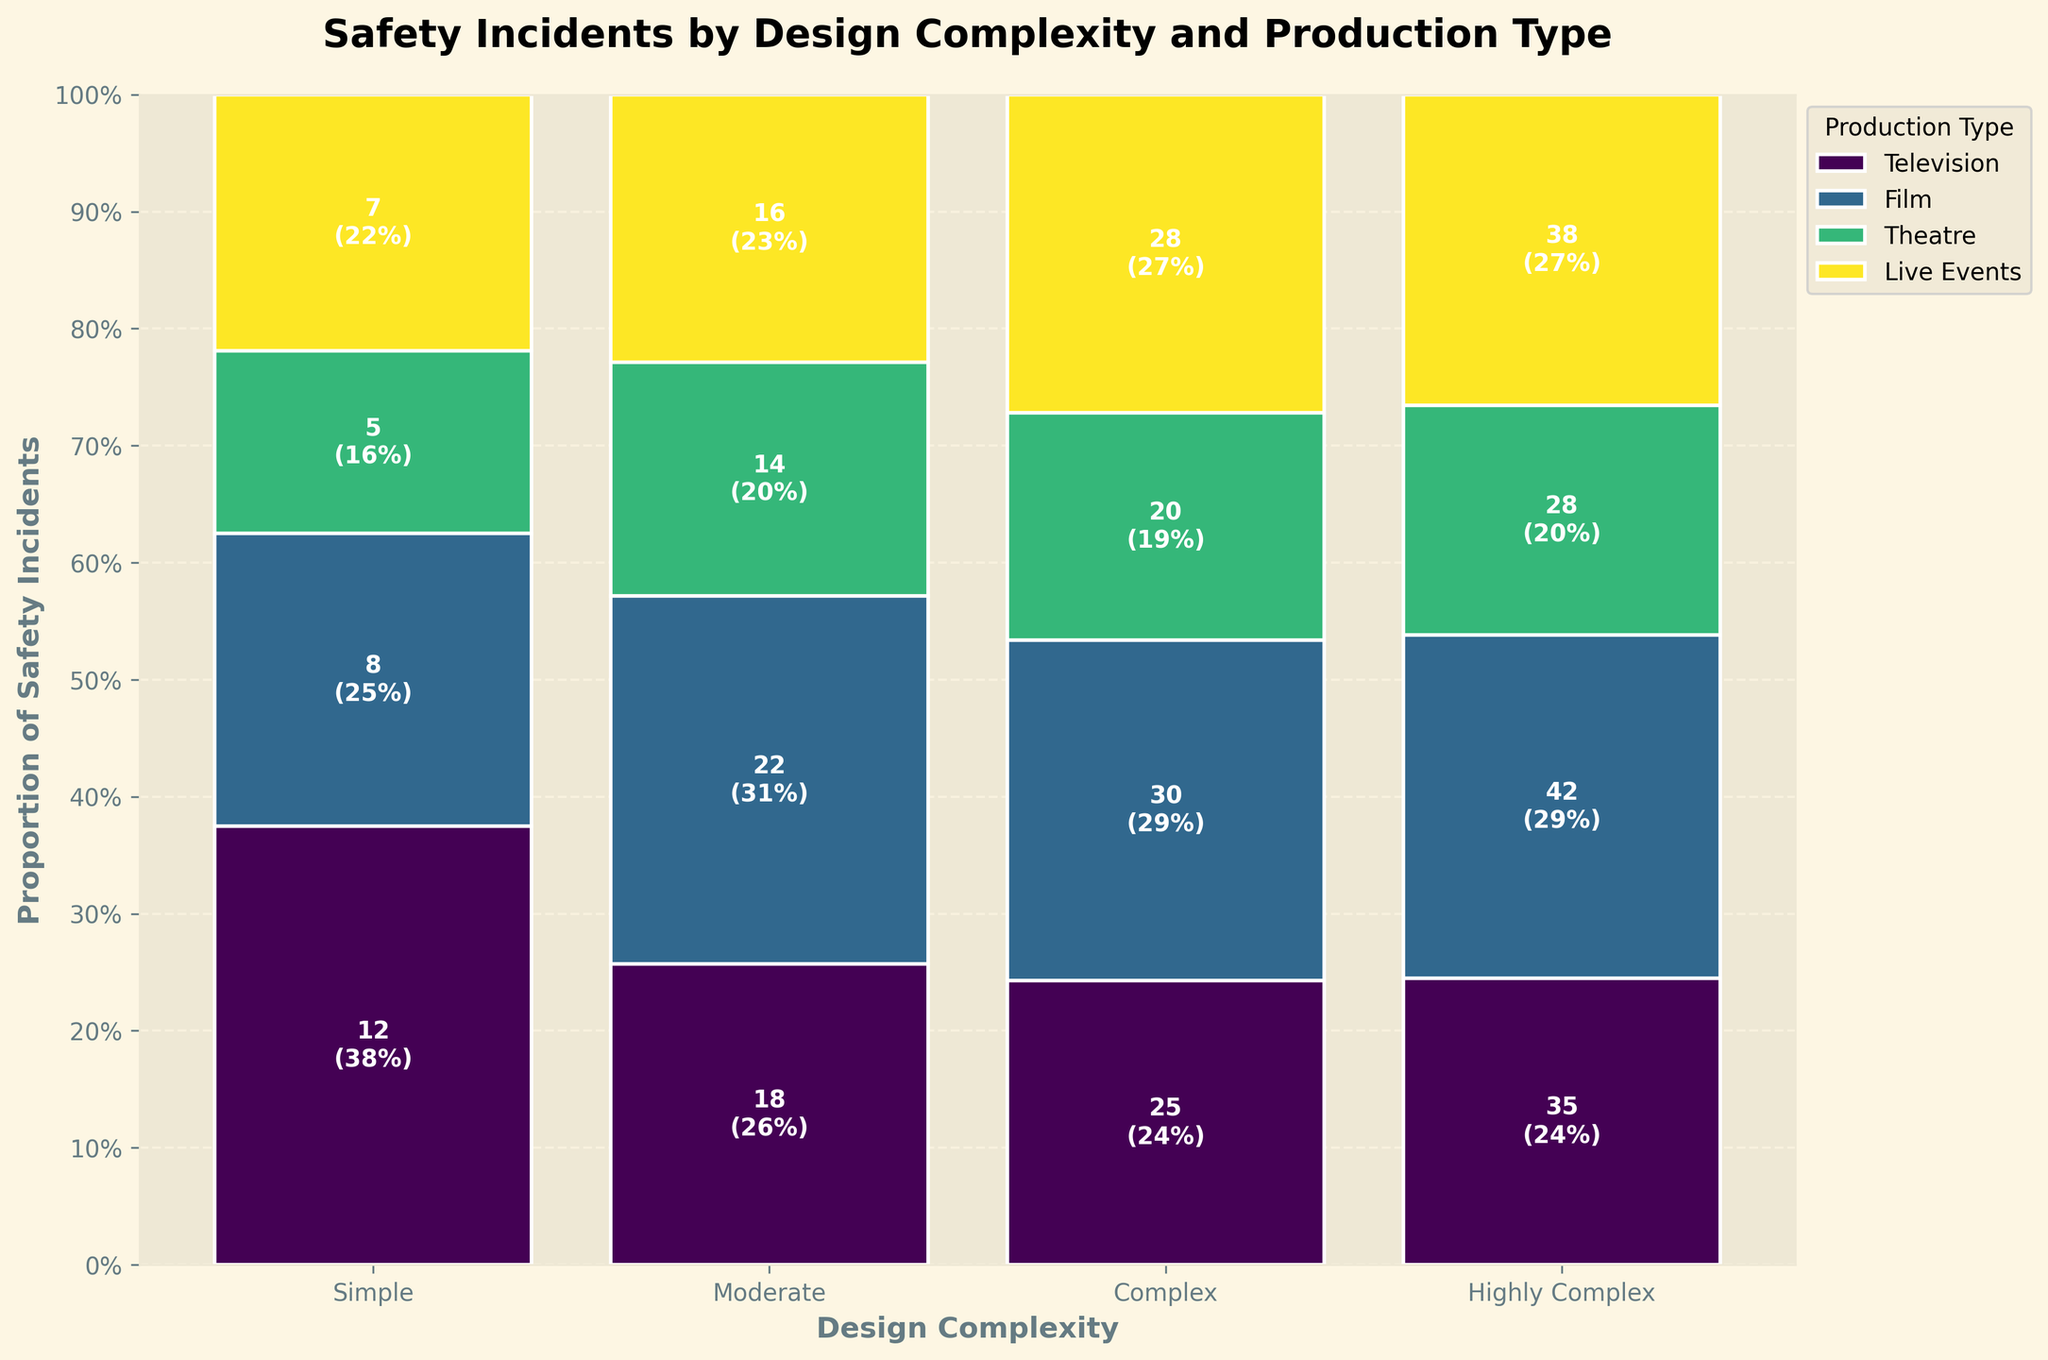What proportion of safety incidents occur in the 'Theatre' production type for moderate design complexity? Check the moderate complexity section's 'Theatre' bar, which should be labeled with both the count and percentage. The label indicates 14 incidents, translating to about 14/70 (sum of 'Moderate' incidents), or 20%. The exact proportion is given in the label.
Answer: 20% What is the difference in the number of safety incidents between complex and highly complex designs in live events? Look at the number of incidents for "Live Events" under both "Complex" and "Highly Complex." Subtract the former (28) from the latter (38): 38 - 28 = 10.
Answer: 10 Which design complexity category has the least number of total safety incidents? Sum all incidents for each design complexity (e.g., Simple: 12+8+5+7=32). The Simple category has a total of 32, which is the lowest.
Answer: Simple Among the different production types, which shows a consistent increase in safety incidents with increasing design complexity across all design complexity levels? By observing the trend across all complexity levels for each production type, we see that Film consistently increases: Simple (8), Moderate (22), Complex (30), Highly Complex (42).
Answer: Film How many safety incidents are there in total for theatre productions across all design complexities? Add the incidents for 'Theatre' across all categories: 5 (Simple) + 14 (Moderate) + 20 (Complex) + 28 (Highly Complex) = 67.
Answer: 67 What is the average number of safety incidents per design complexity for television productions? Sum the incidents for 'Television' across all complexities (i.e., 12+18+25+35 = 90) and divide by the number of complexities (4): 90 / 4 = 22.5.
Answer: 22.5 Is there a production type that has the same number of safety incidents at two different complexity levels? If so, which production type and which levels? Compare the incident counts across different complexities. Live Events has 28 incidents for both Complex and Highly Complex designs.
Answer: Live Events, Complex and Highly Complex Which production type has the lowest proportion of safety incidents for simple design complexity? For 'Simple' design complexity, check the shortest bar (lowest percentage) which is Theatre with 5 incidents.
Answer: Theatre 